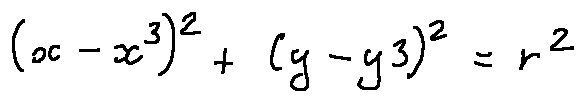Convert formula to latex. <formula><loc_0><loc_0><loc_500><loc_500>( x - x 3 ) ^ { 2 } + ( y - y 3 ) ^ { 2 } = r ^ { 2 }</formula> 